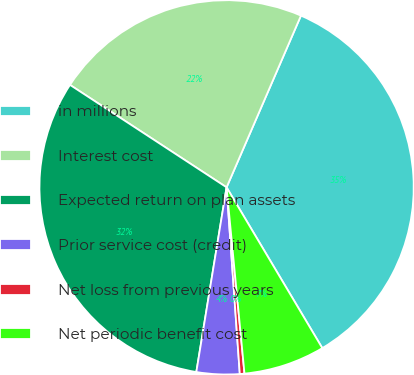Convert chart to OTSL. <chart><loc_0><loc_0><loc_500><loc_500><pie_chart><fcel>in millions<fcel>Interest cost<fcel>Expected return on plan assets<fcel>Prior service cost (credit)<fcel>Net loss from previous years<fcel>Net periodic benefit cost<nl><fcel>34.94%<fcel>22.28%<fcel>31.63%<fcel>3.71%<fcel>0.4%<fcel>7.02%<nl></chart> 